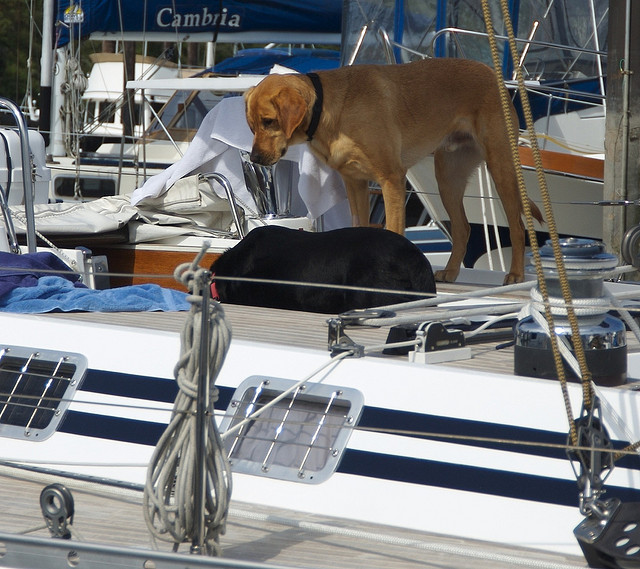Please transcribe the text information in this image. Cambria 